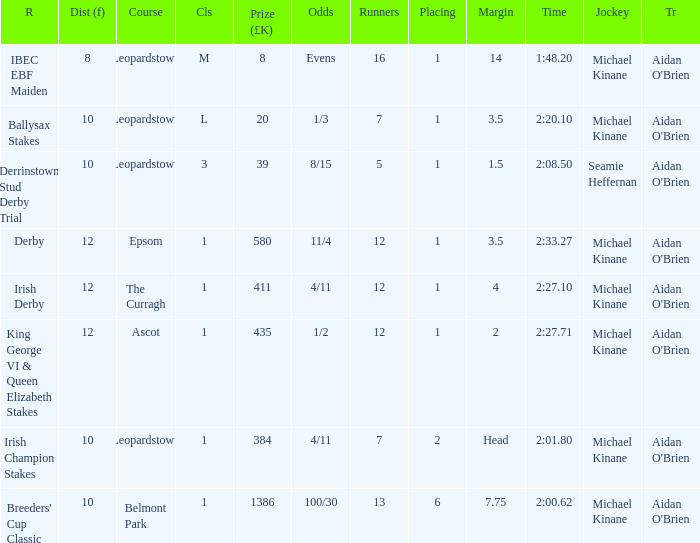Which Margin has a Dist (f) larger than 10, and a Race of king george vi & queen elizabeth stakes? 2.0. 